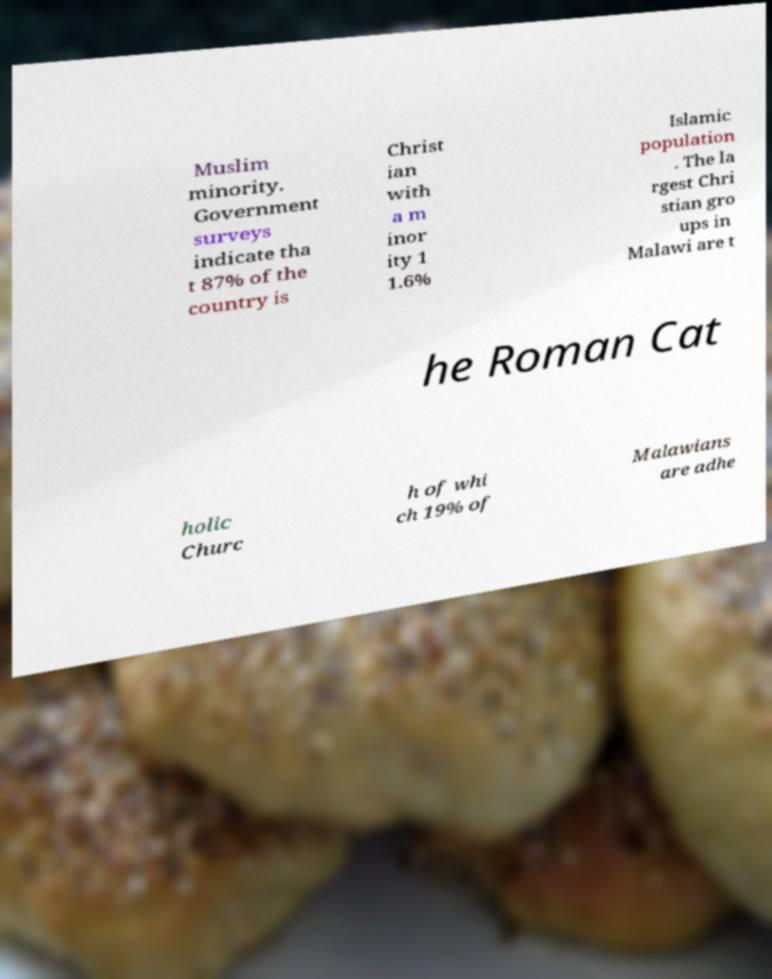Can you read and provide the text displayed in the image?This photo seems to have some interesting text. Can you extract and type it out for me? Muslim minority. Government surveys indicate tha t 87% of the country is Christ ian with a m inor ity 1 1.6% Islamic population . The la rgest Chri stian gro ups in Malawi are t he Roman Cat holic Churc h of whi ch 19% of Malawians are adhe 